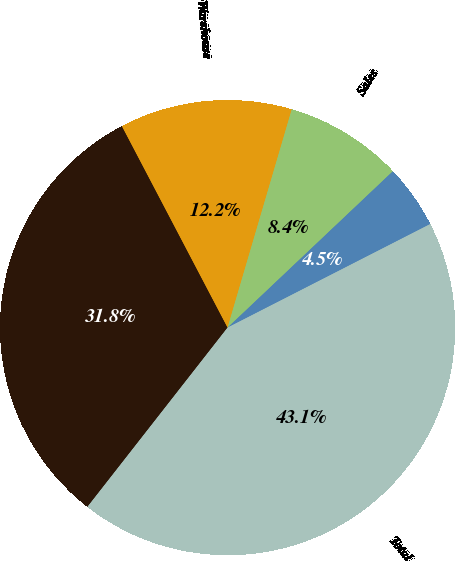<chart> <loc_0><loc_0><loc_500><loc_500><pie_chart><fcel>Production 1<fcel>Warehouse<fcel>Sales<fcel>Administration<fcel>Total<nl><fcel>31.75%<fcel>12.24%<fcel>8.39%<fcel>4.54%<fcel>43.08%<nl></chart> 